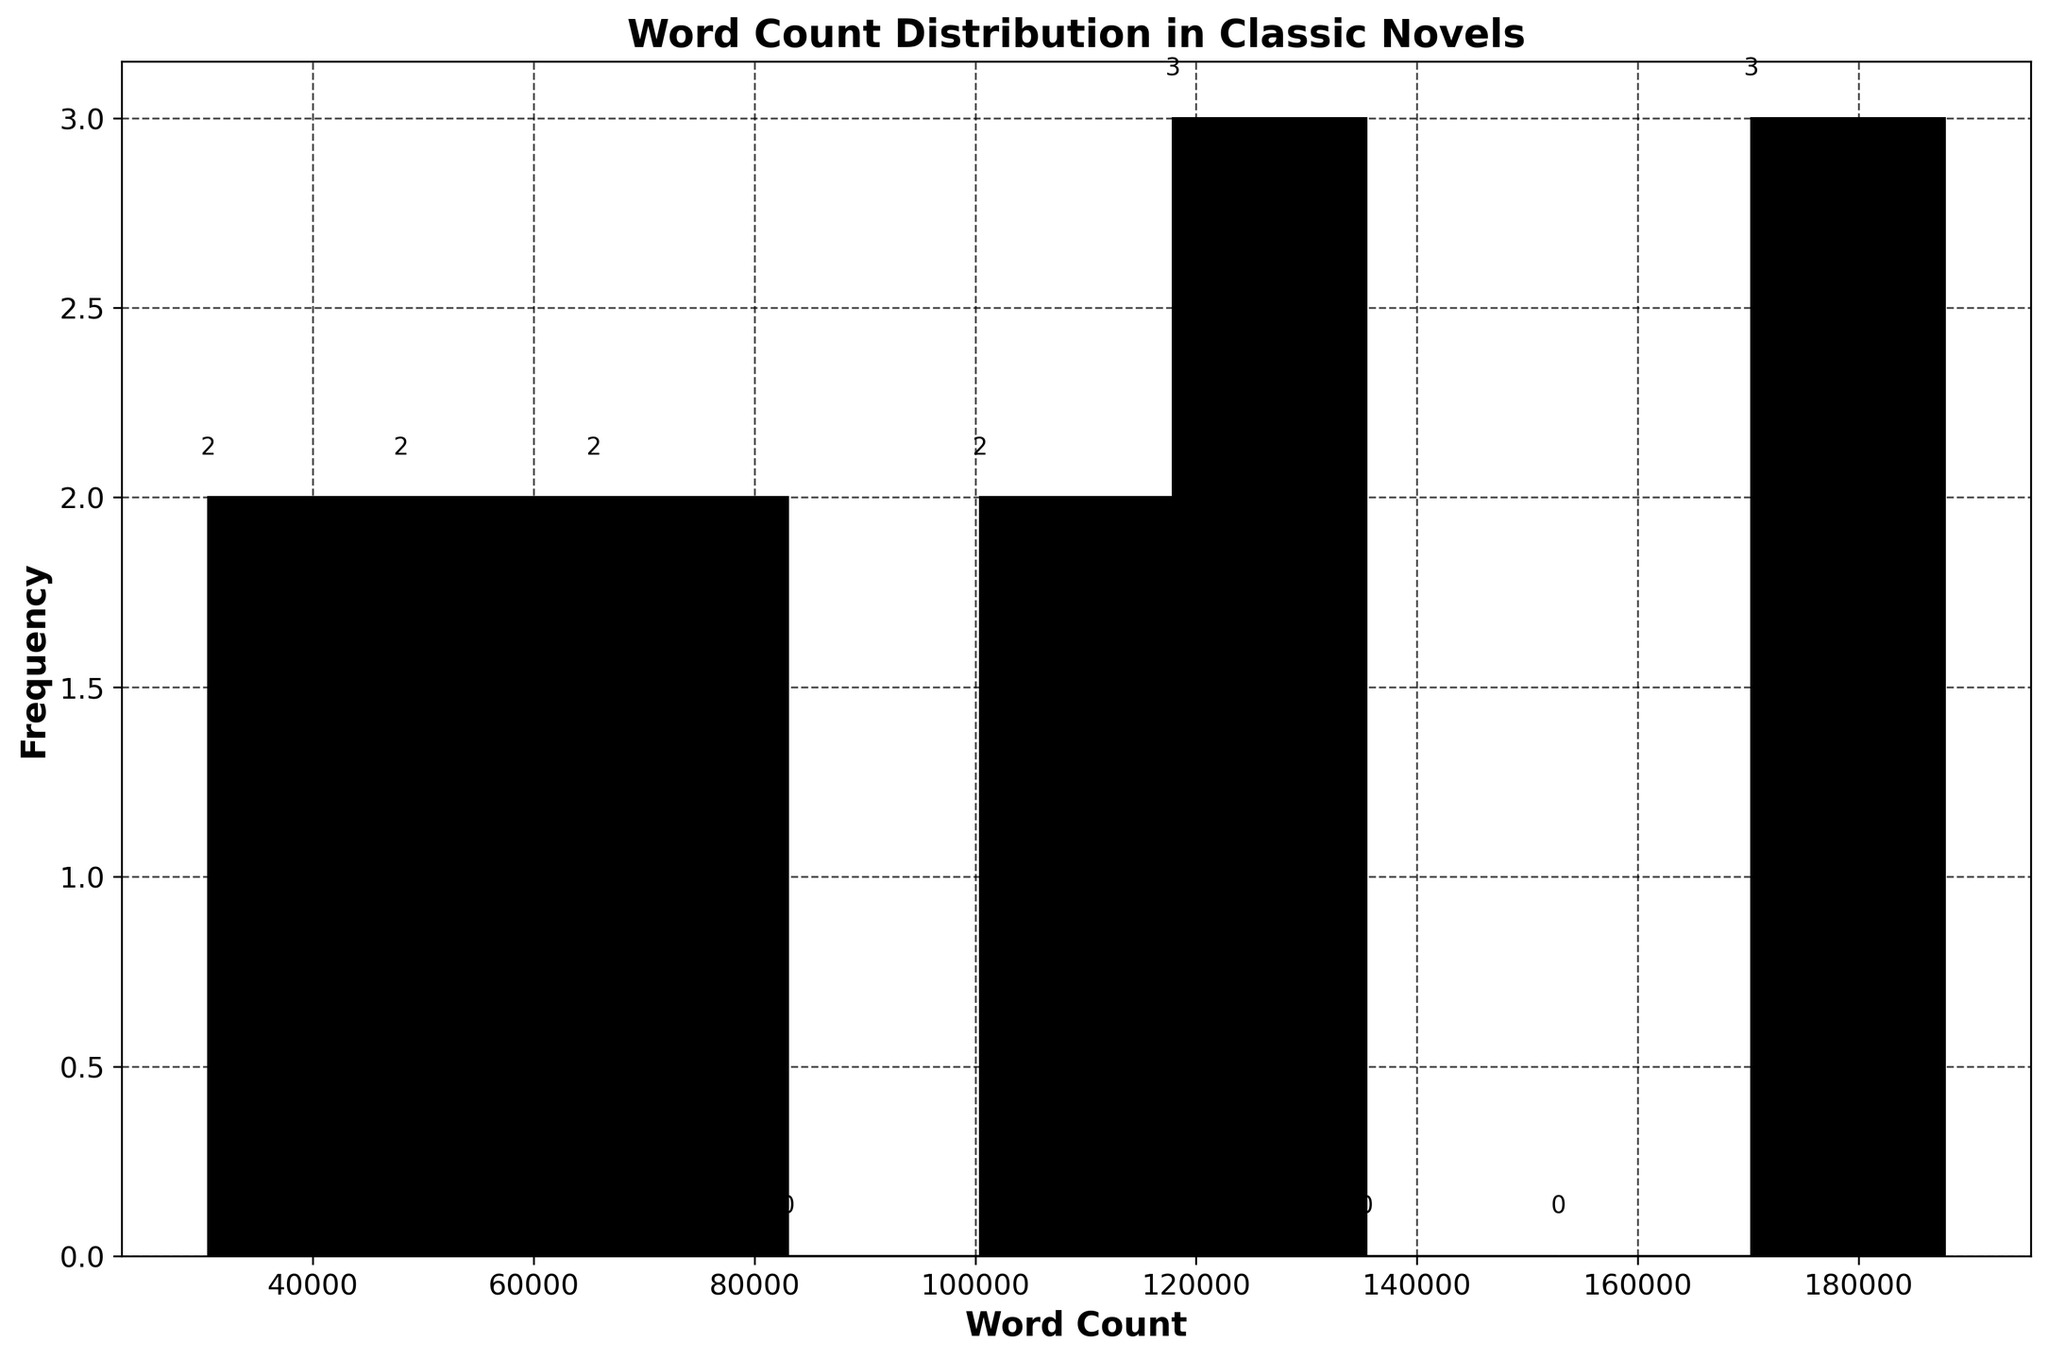What's the title of the figure? The title of the figure is clearly stated at the top of the plot, which summarizes the primary focus of the figure.
Answer: Word Count Distribution in Classic Novels What is the range of word counts displayed on the x-axis? The x-axis shows the word count range, which helps to understand the distribution span of the word counts in the classic novels.
Answer: Approximately 30,000 to 190,000 How many bins are used in the histogram? By counting the distinct intervals or vertical bars in the histogram, you can determine the number of bins used to group the word counts.
Answer: 10 Which bin has the highest frequency of novels? By observing the height of each bin (vertical bar), you can identify which one has the maximum height, indicating the highest count of novels.
Answer: The bin between approximately 110,000 and 130,000 How many novels fall within the bin ranging from 50,000 to 70,000? The count of novels in this specific bin can be directly read from the plot, where each bin indicates the number of novels within its range.
Answer: 1 What is the average word count for novels in the Romanticism period? To find the average, locate the novels from the Romanticism period and calculate the mean of their word counts: (122,189 + 75,067) / 2.
Answer: 98,628 How do word counts in the Victorian period compare to those in the Modernism period? Sum the word counts of the novels in each period and compare: Victorian (Great Expectations + Jane Eyre) and Modernism (To the Lighthouse + Mrs Dalloway).
Answer: Victorian novels have higher word counts Which literary period has the novel with the shortest word count? Identify the novel with the smallest word count by looking for the shortest bar and then find its corresponding literary period.
Answer: Postmodernism (Slaughterhouse-Five) What is the sum of the word counts for novels in the Postmodernism period? Add the word counts of the novels categorized under the Postmodernism period: Catch-22 and Slaughterhouse-Five.
Answer: 223,728 Can you identify a trend in word counts from Renaissance to Contemporary periods? Observe the general pattern of word counts across the literary periods to generalize whether they increase, decrease, or show no clear trend.
Answer: No clear trend 